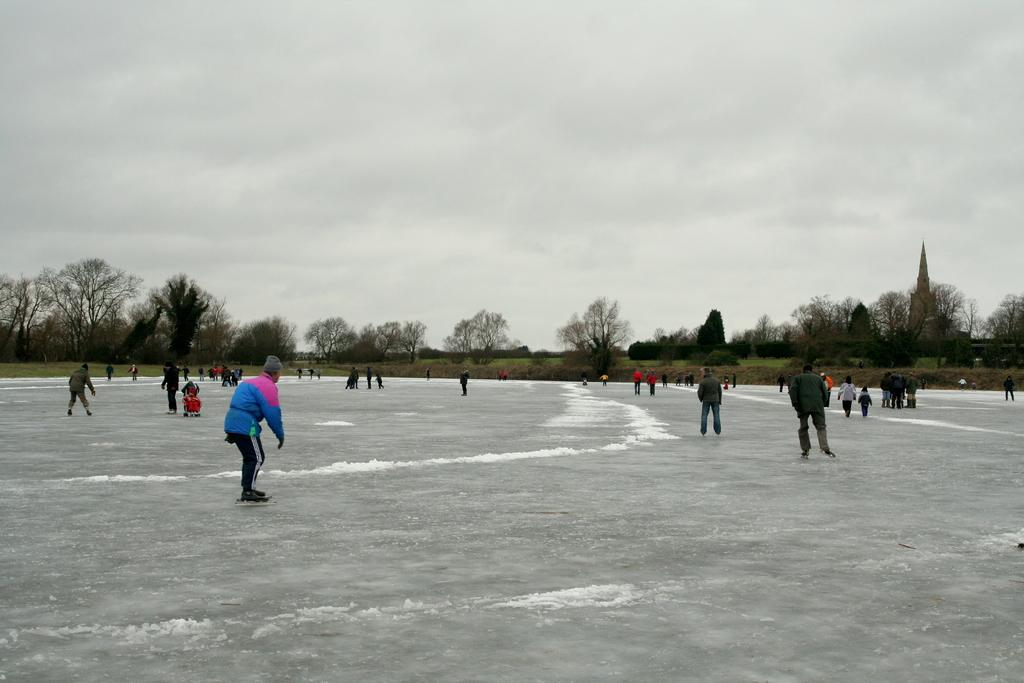What is the condition of the sky in the image? The sky is cloudy in the image. Can you identify any individuals in the image? Yes, there are people visible in the image. What can be seen in the background of the image? The background of the image includes people. How many sisters are present on the tray in the image? There is no tray or sisters present in the image. 